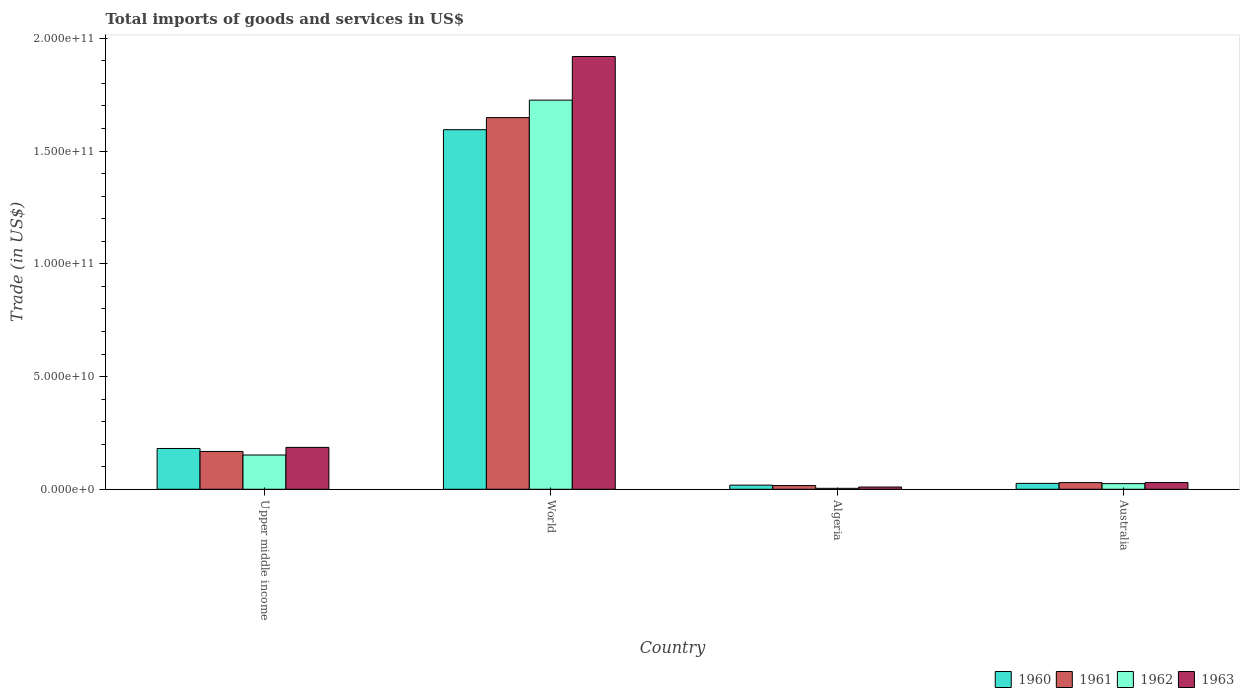How many different coloured bars are there?
Offer a terse response. 4. Are the number of bars per tick equal to the number of legend labels?
Offer a terse response. Yes. Are the number of bars on each tick of the X-axis equal?
Keep it short and to the point. Yes. How many bars are there on the 1st tick from the left?
Offer a terse response. 4. What is the label of the 1st group of bars from the left?
Ensure brevity in your answer.  Upper middle income. In how many cases, is the number of bars for a given country not equal to the number of legend labels?
Give a very brief answer. 0. What is the total imports of goods and services in 1961 in World?
Your answer should be compact. 1.65e+11. Across all countries, what is the maximum total imports of goods and services in 1963?
Provide a succinct answer. 1.92e+11. Across all countries, what is the minimum total imports of goods and services in 1961?
Ensure brevity in your answer.  1.64e+09. In which country was the total imports of goods and services in 1961 maximum?
Your answer should be compact. World. In which country was the total imports of goods and services in 1962 minimum?
Your answer should be compact. Algeria. What is the total total imports of goods and services in 1963 in the graph?
Give a very brief answer. 2.15e+11. What is the difference between the total imports of goods and services in 1962 in Australia and that in Upper middle income?
Ensure brevity in your answer.  -1.27e+1. What is the difference between the total imports of goods and services in 1961 in Upper middle income and the total imports of goods and services in 1962 in World?
Offer a very short reply. -1.56e+11. What is the average total imports of goods and services in 1961 per country?
Provide a short and direct response. 4.66e+1. What is the difference between the total imports of goods and services of/in 1960 and total imports of goods and services of/in 1962 in Algeria?
Make the answer very short. 1.41e+09. What is the ratio of the total imports of goods and services in 1960 in Algeria to that in Upper middle income?
Make the answer very short. 0.1. Is the total imports of goods and services in 1962 in Algeria less than that in Upper middle income?
Give a very brief answer. Yes. What is the difference between the highest and the second highest total imports of goods and services in 1963?
Offer a terse response. 1.56e+1. What is the difference between the highest and the lowest total imports of goods and services in 1962?
Offer a terse response. 1.72e+11. In how many countries, is the total imports of goods and services in 1960 greater than the average total imports of goods and services in 1960 taken over all countries?
Ensure brevity in your answer.  1. Is the sum of the total imports of goods and services in 1961 in Australia and World greater than the maximum total imports of goods and services in 1963 across all countries?
Provide a succinct answer. No. What does the 3rd bar from the left in Australia represents?
Your response must be concise. 1962. What does the 4th bar from the right in Australia represents?
Make the answer very short. 1960. Is it the case that in every country, the sum of the total imports of goods and services in 1960 and total imports of goods and services in 1961 is greater than the total imports of goods and services in 1962?
Make the answer very short. Yes. How many bars are there?
Your answer should be compact. 16. Are all the bars in the graph horizontal?
Keep it short and to the point. No. How many countries are there in the graph?
Keep it short and to the point. 4. How many legend labels are there?
Your response must be concise. 4. How are the legend labels stacked?
Offer a terse response. Horizontal. What is the title of the graph?
Give a very brief answer. Total imports of goods and services in US$. What is the label or title of the Y-axis?
Provide a succinct answer. Trade (in US$). What is the Trade (in US$) of 1960 in Upper middle income?
Ensure brevity in your answer.  1.81e+1. What is the Trade (in US$) in 1961 in Upper middle income?
Keep it short and to the point. 1.68e+1. What is the Trade (in US$) in 1962 in Upper middle income?
Keep it short and to the point. 1.52e+1. What is the Trade (in US$) of 1963 in Upper middle income?
Keep it short and to the point. 1.86e+1. What is the Trade (in US$) of 1960 in World?
Your response must be concise. 1.59e+11. What is the Trade (in US$) in 1961 in World?
Give a very brief answer. 1.65e+11. What is the Trade (in US$) in 1962 in World?
Your answer should be compact. 1.73e+11. What is the Trade (in US$) in 1963 in World?
Make the answer very short. 1.92e+11. What is the Trade (in US$) in 1960 in Algeria?
Make the answer very short. 1.83e+09. What is the Trade (in US$) of 1961 in Algeria?
Your response must be concise. 1.64e+09. What is the Trade (in US$) in 1962 in Algeria?
Offer a very short reply. 4.17e+08. What is the Trade (in US$) of 1963 in Algeria?
Your response must be concise. 9.95e+08. What is the Trade (in US$) in 1960 in Australia?
Your response must be concise. 2.61e+09. What is the Trade (in US$) in 1961 in Australia?
Your response must be concise. 2.95e+09. What is the Trade (in US$) of 1962 in Australia?
Your answer should be compact. 2.51e+09. What is the Trade (in US$) of 1963 in Australia?
Provide a succinct answer. 2.97e+09. Across all countries, what is the maximum Trade (in US$) in 1960?
Offer a very short reply. 1.59e+11. Across all countries, what is the maximum Trade (in US$) in 1961?
Ensure brevity in your answer.  1.65e+11. Across all countries, what is the maximum Trade (in US$) in 1962?
Give a very brief answer. 1.73e+11. Across all countries, what is the maximum Trade (in US$) of 1963?
Offer a very short reply. 1.92e+11. Across all countries, what is the minimum Trade (in US$) in 1960?
Provide a succinct answer. 1.83e+09. Across all countries, what is the minimum Trade (in US$) in 1961?
Offer a very short reply. 1.64e+09. Across all countries, what is the minimum Trade (in US$) of 1962?
Give a very brief answer. 4.17e+08. Across all countries, what is the minimum Trade (in US$) in 1963?
Provide a succinct answer. 9.95e+08. What is the total Trade (in US$) in 1960 in the graph?
Make the answer very short. 1.82e+11. What is the total Trade (in US$) in 1961 in the graph?
Your answer should be very brief. 1.86e+11. What is the total Trade (in US$) in 1962 in the graph?
Make the answer very short. 1.91e+11. What is the total Trade (in US$) in 1963 in the graph?
Offer a terse response. 2.15e+11. What is the difference between the Trade (in US$) in 1960 in Upper middle income and that in World?
Provide a succinct answer. -1.41e+11. What is the difference between the Trade (in US$) in 1961 in Upper middle income and that in World?
Provide a short and direct response. -1.48e+11. What is the difference between the Trade (in US$) of 1962 in Upper middle income and that in World?
Make the answer very short. -1.57e+11. What is the difference between the Trade (in US$) in 1963 in Upper middle income and that in World?
Your answer should be very brief. -1.73e+11. What is the difference between the Trade (in US$) in 1960 in Upper middle income and that in Algeria?
Offer a terse response. 1.63e+1. What is the difference between the Trade (in US$) of 1961 in Upper middle income and that in Algeria?
Ensure brevity in your answer.  1.51e+1. What is the difference between the Trade (in US$) in 1962 in Upper middle income and that in Algeria?
Your answer should be compact. 1.48e+1. What is the difference between the Trade (in US$) of 1963 in Upper middle income and that in Algeria?
Offer a very short reply. 1.76e+1. What is the difference between the Trade (in US$) of 1960 in Upper middle income and that in Australia?
Provide a succinct answer. 1.55e+1. What is the difference between the Trade (in US$) of 1961 in Upper middle income and that in Australia?
Your answer should be very brief. 1.38e+1. What is the difference between the Trade (in US$) of 1962 in Upper middle income and that in Australia?
Make the answer very short. 1.27e+1. What is the difference between the Trade (in US$) in 1963 in Upper middle income and that in Australia?
Provide a short and direct response. 1.56e+1. What is the difference between the Trade (in US$) of 1960 in World and that in Algeria?
Ensure brevity in your answer.  1.58e+11. What is the difference between the Trade (in US$) of 1961 in World and that in Algeria?
Offer a very short reply. 1.63e+11. What is the difference between the Trade (in US$) in 1962 in World and that in Algeria?
Ensure brevity in your answer.  1.72e+11. What is the difference between the Trade (in US$) of 1963 in World and that in Algeria?
Your answer should be very brief. 1.91e+11. What is the difference between the Trade (in US$) of 1960 in World and that in Australia?
Offer a terse response. 1.57e+11. What is the difference between the Trade (in US$) of 1961 in World and that in Australia?
Your answer should be very brief. 1.62e+11. What is the difference between the Trade (in US$) of 1962 in World and that in Australia?
Your answer should be compact. 1.70e+11. What is the difference between the Trade (in US$) in 1963 in World and that in Australia?
Your answer should be compact. 1.89e+11. What is the difference between the Trade (in US$) in 1960 in Algeria and that in Australia?
Provide a succinct answer. -7.83e+08. What is the difference between the Trade (in US$) in 1961 in Algeria and that in Australia?
Give a very brief answer. -1.31e+09. What is the difference between the Trade (in US$) of 1962 in Algeria and that in Australia?
Your response must be concise. -2.10e+09. What is the difference between the Trade (in US$) of 1963 in Algeria and that in Australia?
Your answer should be compact. -1.98e+09. What is the difference between the Trade (in US$) of 1960 in Upper middle income and the Trade (in US$) of 1961 in World?
Give a very brief answer. -1.47e+11. What is the difference between the Trade (in US$) of 1960 in Upper middle income and the Trade (in US$) of 1962 in World?
Your answer should be compact. -1.55e+11. What is the difference between the Trade (in US$) in 1960 in Upper middle income and the Trade (in US$) in 1963 in World?
Offer a very short reply. -1.74e+11. What is the difference between the Trade (in US$) in 1961 in Upper middle income and the Trade (in US$) in 1962 in World?
Give a very brief answer. -1.56e+11. What is the difference between the Trade (in US$) of 1961 in Upper middle income and the Trade (in US$) of 1963 in World?
Ensure brevity in your answer.  -1.75e+11. What is the difference between the Trade (in US$) in 1962 in Upper middle income and the Trade (in US$) in 1963 in World?
Provide a short and direct response. -1.77e+11. What is the difference between the Trade (in US$) of 1960 in Upper middle income and the Trade (in US$) of 1961 in Algeria?
Ensure brevity in your answer.  1.65e+1. What is the difference between the Trade (in US$) in 1960 in Upper middle income and the Trade (in US$) in 1962 in Algeria?
Provide a succinct answer. 1.77e+1. What is the difference between the Trade (in US$) in 1960 in Upper middle income and the Trade (in US$) in 1963 in Algeria?
Provide a short and direct response. 1.71e+1. What is the difference between the Trade (in US$) in 1961 in Upper middle income and the Trade (in US$) in 1962 in Algeria?
Your response must be concise. 1.64e+1. What is the difference between the Trade (in US$) in 1961 in Upper middle income and the Trade (in US$) in 1963 in Algeria?
Provide a short and direct response. 1.58e+1. What is the difference between the Trade (in US$) of 1962 in Upper middle income and the Trade (in US$) of 1963 in Algeria?
Give a very brief answer. 1.42e+1. What is the difference between the Trade (in US$) of 1960 in Upper middle income and the Trade (in US$) of 1961 in Australia?
Your answer should be very brief. 1.51e+1. What is the difference between the Trade (in US$) of 1960 in Upper middle income and the Trade (in US$) of 1962 in Australia?
Provide a short and direct response. 1.56e+1. What is the difference between the Trade (in US$) in 1960 in Upper middle income and the Trade (in US$) in 1963 in Australia?
Provide a succinct answer. 1.51e+1. What is the difference between the Trade (in US$) of 1961 in Upper middle income and the Trade (in US$) of 1962 in Australia?
Offer a very short reply. 1.43e+1. What is the difference between the Trade (in US$) in 1961 in Upper middle income and the Trade (in US$) in 1963 in Australia?
Provide a short and direct response. 1.38e+1. What is the difference between the Trade (in US$) of 1962 in Upper middle income and the Trade (in US$) of 1963 in Australia?
Offer a very short reply. 1.22e+1. What is the difference between the Trade (in US$) of 1960 in World and the Trade (in US$) of 1961 in Algeria?
Make the answer very short. 1.58e+11. What is the difference between the Trade (in US$) in 1960 in World and the Trade (in US$) in 1962 in Algeria?
Keep it short and to the point. 1.59e+11. What is the difference between the Trade (in US$) of 1960 in World and the Trade (in US$) of 1963 in Algeria?
Provide a short and direct response. 1.58e+11. What is the difference between the Trade (in US$) of 1961 in World and the Trade (in US$) of 1962 in Algeria?
Your answer should be compact. 1.64e+11. What is the difference between the Trade (in US$) in 1961 in World and the Trade (in US$) in 1963 in Algeria?
Offer a terse response. 1.64e+11. What is the difference between the Trade (in US$) in 1962 in World and the Trade (in US$) in 1963 in Algeria?
Your response must be concise. 1.72e+11. What is the difference between the Trade (in US$) in 1960 in World and the Trade (in US$) in 1961 in Australia?
Your answer should be compact. 1.57e+11. What is the difference between the Trade (in US$) in 1960 in World and the Trade (in US$) in 1962 in Australia?
Ensure brevity in your answer.  1.57e+11. What is the difference between the Trade (in US$) of 1960 in World and the Trade (in US$) of 1963 in Australia?
Your answer should be very brief. 1.57e+11. What is the difference between the Trade (in US$) of 1961 in World and the Trade (in US$) of 1962 in Australia?
Ensure brevity in your answer.  1.62e+11. What is the difference between the Trade (in US$) in 1961 in World and the Trade (in US$) in 1963 in Australia?
Your answer should be very brief. 1.62e+11. What is the difference between the Trade (in US$) in 1962 in World and the Trade (in US$) in 1963 in Australia?
Ensure brevity in your answer.  1.70e+11. What is the difference between the Trade (in US$) in 1960 in Algeria and the Trade (in US$) in 1961 in Australia?
Give a very brief answer. -1.12e+09. What is the difference between the Trade (in US$) of 1960 in Algeria and the Trade (in US$) of 1962 in Australia?
Your answer should be compact. -6.83e+08. What is the difference between the Trade (in US$) in 1960 in Algeria and the Trade (in US$) in 1963 in Australia?
Your response must be concise. -1.15e+09. What is the difference between the Trade (in US$) of 1961 in Algeria and the Trade (in US$) of 1962 in Australia?
Make the answer very short. -8.68e+08. What is the difference between the Trade (in US$) in 1961 in Algeria and the Trade (in US$) in 1963 in Australia?
Make the answer very short. -1.33e+09. What is the difference between the Trade (in US$) of 1962 in Algeria and the Trade (in US$) of 1963 in Australia?
Your answer should be very brief. -2.56e+09. What is the average Trade (in US$) of 1960 per country?
Make the answer very short. 4.55e+1. What is the average Trade (in US$) of 1961 per country?
Provide a succinct answer. 4.66e+1. What is the average Trade (in US$) of 1962 per country?
Make the answer very short. 4.77e+1. What is the average Trade (in US$) in 1963 per country?
Keep it short and to the point. 5.36e+1. What is the difference between the Trade (in US$) of 1960 and Trade (in US$) of 1961 in Upper middle income?
Your answer should be compact. 1.32e+09. What is the difference between the Trade (in US$) of 1960 and Trade (in US$) of 1962 in Upper middle income?
Provide a short and direct response. 2.90e+09. What is the difference between the Trade (in US$) in 1960 and Trade (in US$) in 1963 in Upper middle income?
Provide a short and direct response. -4.87e+08. What is the difference between the Trade (in US$) of 1961 and Trade (in US$) of 1962 in Upper middle income?
Offer a terse response. 1.58e+09. What is the difference between the Trade (in US$) in 1961 and Trade (in US$) in 1963 in Upper middle income?
Offer a terse response. -1.81e+09. What is the difference between the Trade (in US$) in 1962 and Trade (in US$) in 1963 in Upper middle income?
Make the answer very short. -3.39e+09. What is the difference between the Trade (in US$) of 1960 and Trade (in US$) of 1961 in World?
Provide a short and direct response. -5.36e+09. What is the difference between the Trade (in US$) in 1960 and Trade (in US$) in 1962 in World?
Give a very brief answer. -1.31e+1. What is the difference between the Trade (in US$) in 1960 and Trade (in US$) in 1963 in World?
Provide a succinct answer. -3.25e+1. What is the difference between the Trade (in US$) in 1961 and Trade (in US$) in 1962 in World?
Your answer should be very brief. -7.75e+09. What is the difference between the Trade (in US$) of 1961 and Trade (in US$) of 1963 in World?
Offer a very short reply. -2.71e+1. What is the difference between the Trade (in US$) of 1962 and Trade (in US$) of 1963 in World?
Offer a very short reply. -1.93e+1. What is the difference between the Trade (in US$) of 1960 and Trade (in US$) of 1961 in Algeria?
Keep it short and to the point. 1.85e+08. What is the difference between the Trade (in US$) of 1960 and Trade (in US$) of 1962 in Algeria?
Your answer should be very brief. 1.41e+09. What is the difference between the Trade (in US$) in 1960 and Trade (in US$) in 1963 in Algeria?
Offer a terse response. 8.33e+08. What is the difference between the Trade (in US$) of 1961 and Trade (in US$) of 1962 in Algeria?
Your response must be concise. 1.23e+09. What is the difference between the Trade (in US$) of 1961 and Trade (in US$) of 1963 in Algeria?
Provide a succinct answer. 6.48e+08. What is the difference between the Trade (in US$) of 1962 and Trade (in US$) of 1963 in Algeria?
Provide a succinct answer. -5.79e+08. What is the difference between the Trade (in US$) of 1960 and Trade (in US$) of 1961 in Australia?
Provide a succinct answer. -3.40e+08. What is the difference between the Trade (in US$) in 1960 and Trade (in US$) in 1962 in Australia?
Provide a short and direct response. 9.97e+07. What is the difference between the Trade (in US$) in 1960 and Trade (in US$) in 1963 in Australia?
Keep it short and to the point. -3.63e+08. What is the difference between the Trade (in US$) of 1961 and Trade (in US$) of 1962 in Australia?
Ensure brevity in your answer.  4.40e+08. What is the difference between the Trade (in US$) in 1961 and Trade (in US$) in 1963 in Australia?
Your response must be concise. -2.24e+07. What is the difference between the Trade (in US$) of 1962 and Trade (in US$) of 1963 in Australia?
Keep it short and to the point. -4.63e+08. What is the ratio of the Trade (in US$) in 1960 in Upper middle income to that in World?
Offer a terse response. 0.11. What is the ratio of the Trade (in US$) of 1961 in Upper middle income to that in World?
Offer a terse response. 0.1. What is the ratio of the Trade (in US$) of 1962 in Upper middle income to that in World?
Provide a short and direct response. 0.09. What is the ratio of the Trade (in US$) of 1963 in Upper middle income to that in World?
Provide a short and direct response. 0.1. What is the ratio of the Trade (in US$) of 1960 in Upper middle income to that in Algeria?
Provide a short and direct response. 9.89. What is the ratio of the Trade (in US$) in 1961 in Upper middle income to that in Algeria?
Give a very brief answer. 10.21. What is the ratio of the Trade (in US$) of 1962 in Upper middle income to that in Algeria?
Provide a succinct answer. 36.47. What is the ratio of the Trade (in US$) of 1963 in Upper middle income to that in Algeria?
Your answer should be compact. 18.67. What is the ratio of the Trade (in US$) in 1960 in Upper middle income to that in Australia?
Your response must be concise. 6.93. What is the ratio of the Trade (in US$) of 1961 in Upper middle income to that in Australia?
Your response must be concise. 5.68. What is the ratio of the Trade (in US$) in 1962 in Upper middle income to that in Australia?
Ensure brevity in your answer.  6.05. What is the ratio of the Trade (in US$) of 1963 in Upper middle income to that in Australia?
Your response must be concise. 6.25. What is the ratio of the Trade (in US$) of 1960 in World to that in Algeria?
Your response must be concise. 87.21. What is the ratio of the Trade (in US$) of 1961 in World to that in Algeria?
Make the answer very short. 100.3. What is the ratio of the Trade (in US$) of 1962 in World to that in Algeria?
Provide a succinct answer. 414.23. What is the ratio of the Trade (in US$) in 1963 in World to that in Algeria?
Offer a terse response. 192.84. What is the ratio of the Trade (in US$) of 1960 in World to that in Australia?
Keep it short and to the point. 61.07. What is the ratio of the Trade (in US$) of 1961 in World to that in Australia?
Ensure brevity in your answer.  55.84. What is the ratio of the Trade (in US$) in 1962 in World to that in Australia?
Give a very brief answer. 68.71. What is the ratio of the Trade (in US$) of 1963 in World to that in Australia?
Ensure brevity in your answer.  64.53. What is the ratio of the Trade (in US$) in 1960 in Algeria to that in Australia?
Your answer should be compact. 0.7. What is the ratio of the Trade (in US$) of 1961 in Algeria to that in Australia?
Offer a very short reply. 0.56. What is the ratio of the Trade (in US$) in 1962 in Algeria to that in Australia?
Your response must be concise. 0.17. What is the ratio of the Trade (in US$) of 1963 in Algeria to that in Australia?
Offer a very short reply. 0.33. What is the difference between the highest and the second highest Trade (in US$) in 1960?
Provide a short and direct response. 1.41e+11. What is the difference between the highest and the second highest Trade (in US$) of 1961?
Make the answer very short. 1.48e+11. What is the difference between the highest and the second highest Trade (in US$) of 1962?
Your answer should be very brief. 1.57e+11. What is the difference between the highest and the second highest Trade (in US$) of 1963?
Offer a terse response. 1.73e+11. What is the difference between the highest and the lowest Trade (in US$) of 1960?
Ensure brevity in your answer.  1.58e+11. What is the difference between the highest and the lowest Trade (in US$) of 1961?
Offer a terse response. 1.63e+11. What is the difference between the highest and the lowest Trade (in US$) of 1962?
Ensure brevity in your answer.  1.72e+11. What is the difference between the highest and the lowest Trade (in US$) of 1963?
Make the answer very short. 1.91e+11. 